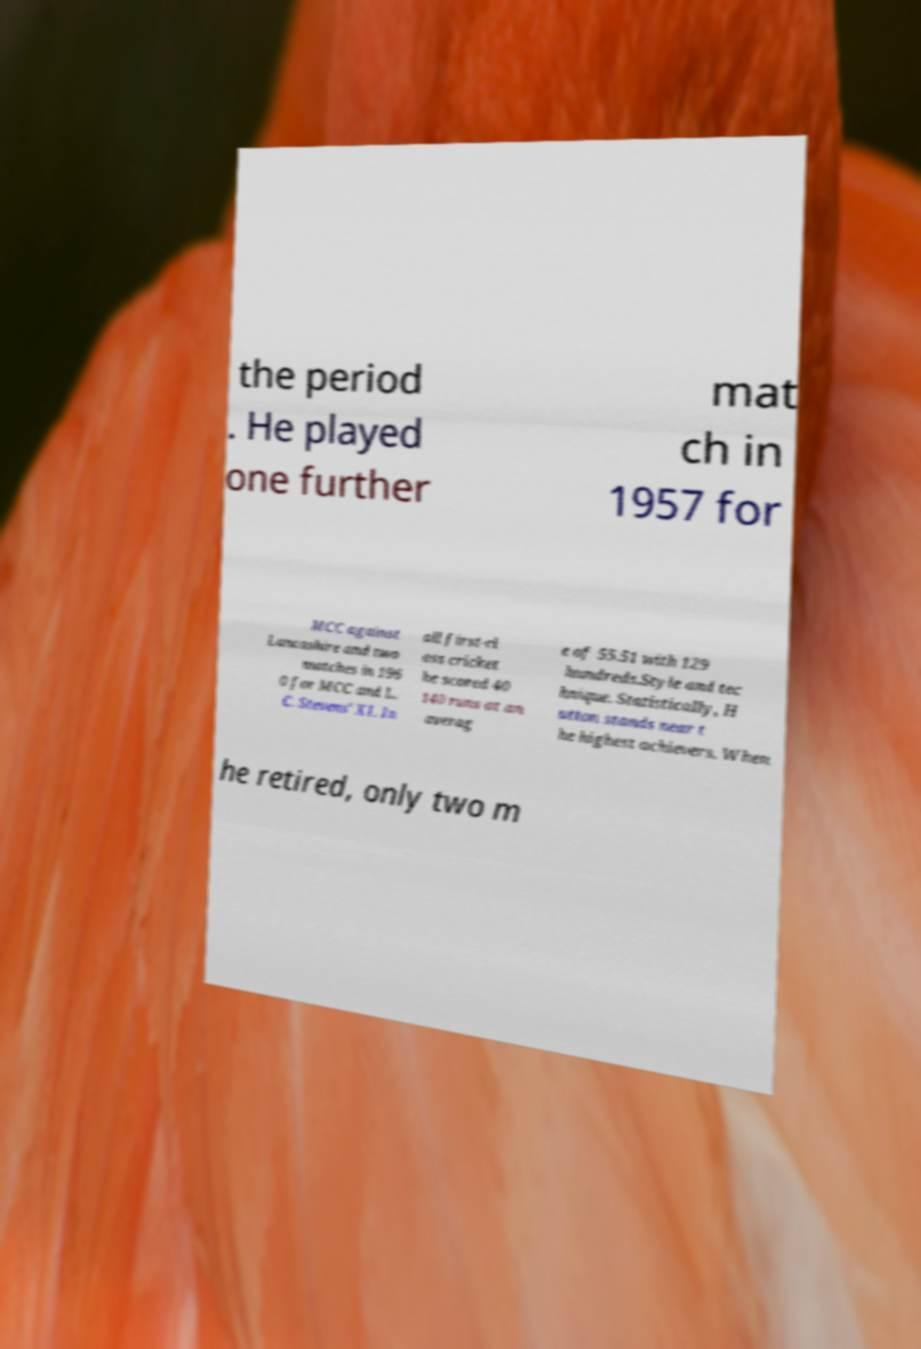For documentation purposes, I need the text within this image transcribed. Could you provide that? the period . He played one further mat ch in 1957 for MCC against Lancashire and two matches in 196 0 for MCC and L. C. Stevens' XI. In all first-cl ass cricket he scored 40 140 runs at an averag e of 55.51 with 129 hundreds.Style and tec hnique. Statistically, H utton stands near t he highest achievers. When he retired, only two m 